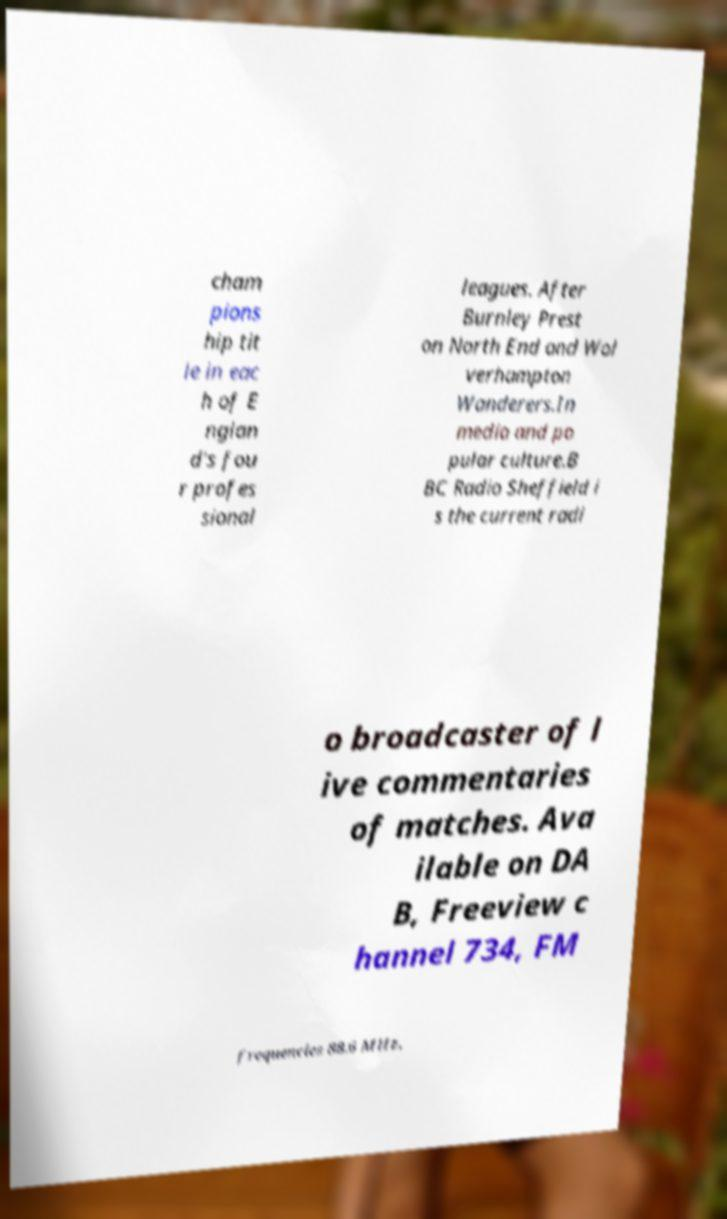There's text embedded in this image that I need extracted. Can you transcribe it verbatim? cham pions hip tit le in eac h of E nglan d's fou r profes sional leagues. After Burnley Prest on North End and Wol verhampton Wanderers.In media and po pular culture.B BC Radio Sheffield i s the current radi o broadcaster of l ive commentaries of matches. Ava ilable on DA B, Freeview c hannel 734, FM frequencies 88.6 MHz, 